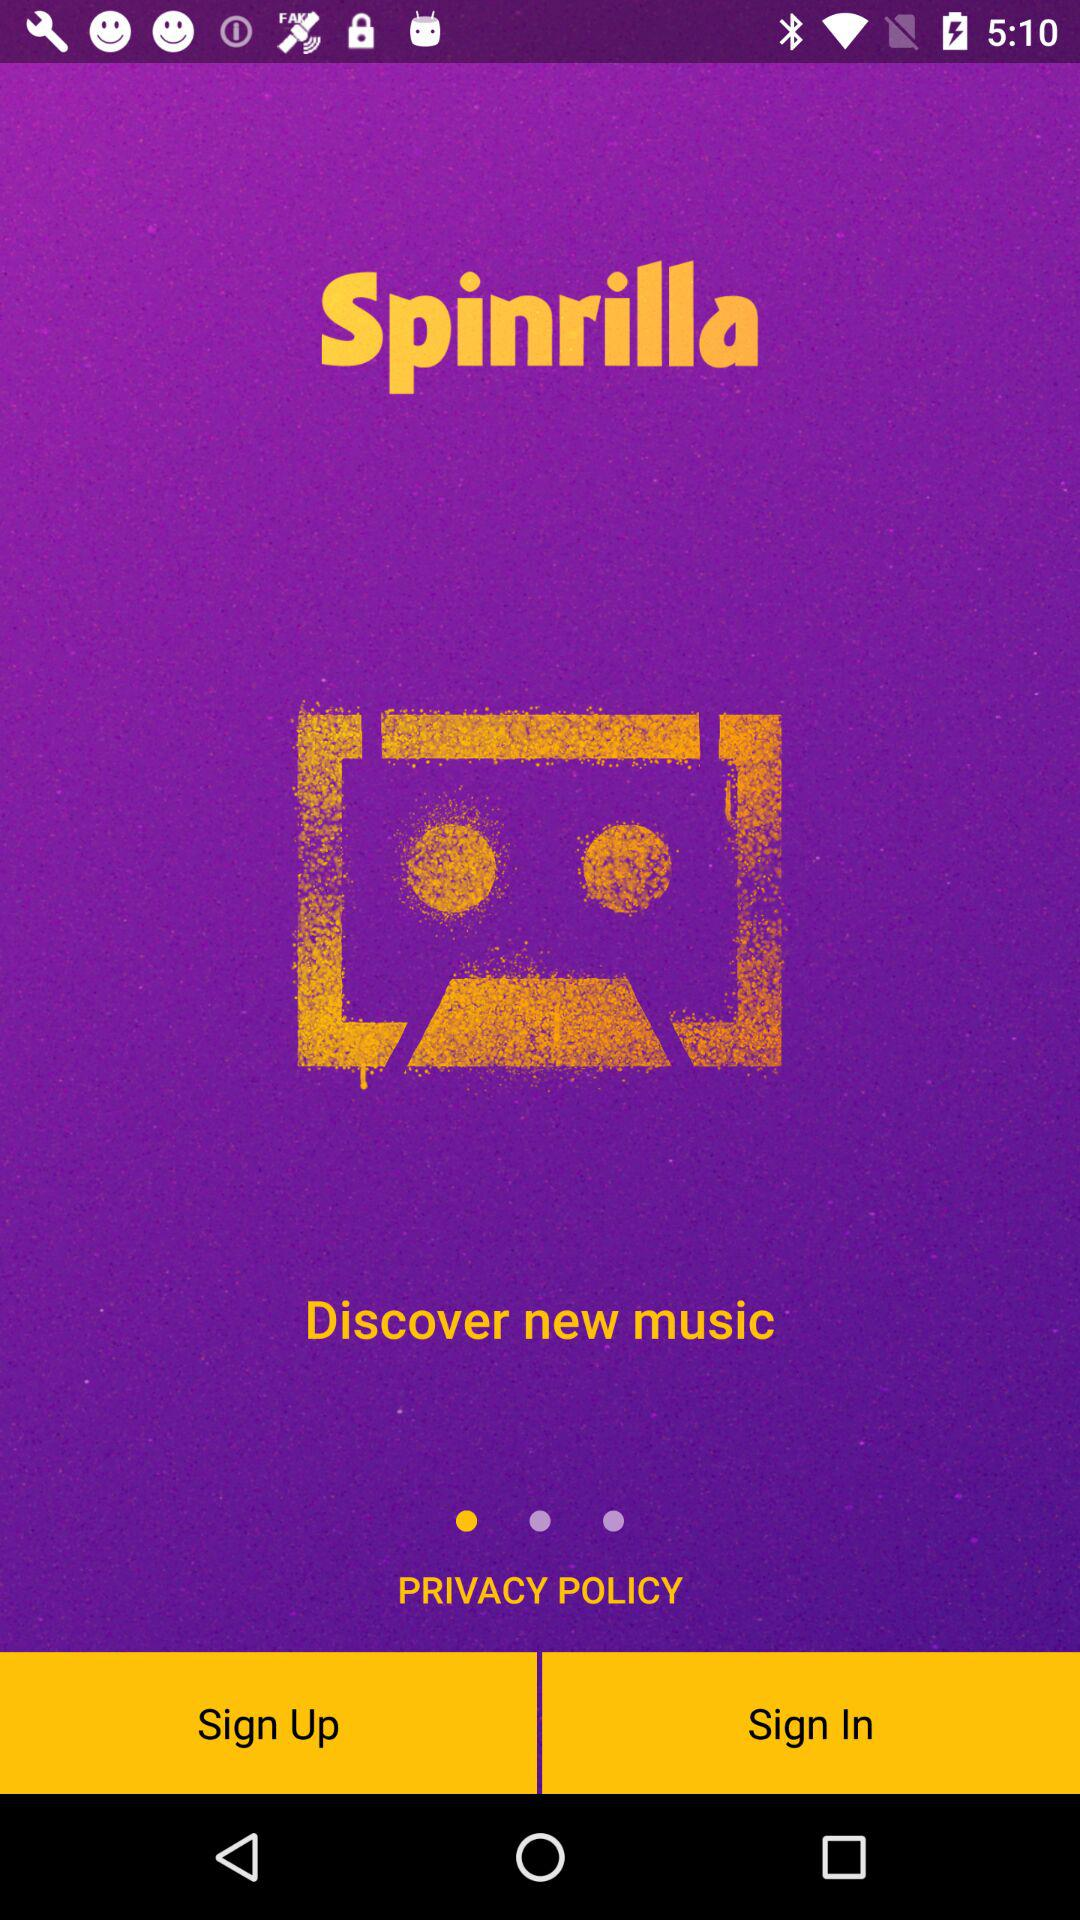What is the name of the application? The name of the application is "Spinrilla". 